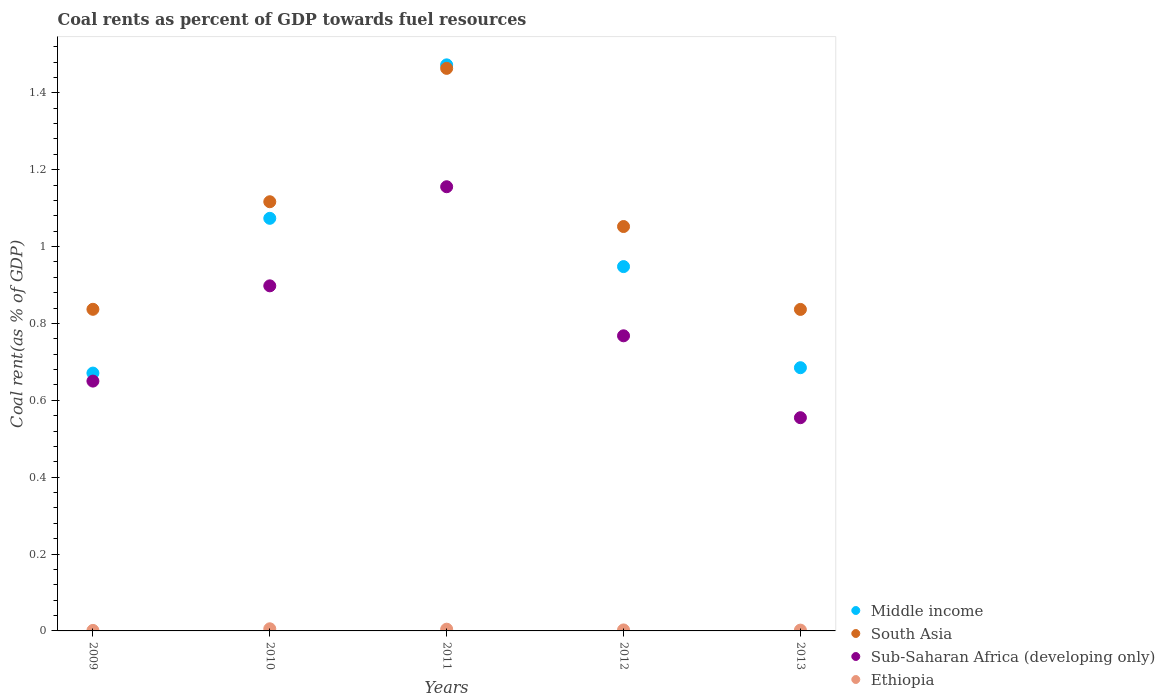How many different coloured dotlines are there?
Provide a short and direct response. 4. What is the coal rent in Middle income in 2012?
Your response must be concise. 0.95. Across all years, what is the maximum coal rent in Middle income?
Your response must be concise. 1.47. Across all years, what is the minimum coal rent in Ethiopia?
Offer a terse response. 0. In which year was the coal rent in Middle income minimum?
Provide a short and direct response. 2009. What is the total coal rent in Sub-Saharan Africa (developing only) in the graph?
Offer a very short reply. 4.03. What is the difference between the coal rent in Ethiopia in 2009 and that in 2010?
Your answer should be very brief. -0. What is the difference between the coal rent in Ethiopia in 2011 and the coal rent in Sub-Saharan Africa (developing only) in 2012?
Offer a very short reply. -0.76. What is the average coal rent in South Asia per year?
Offer a terse response. 1.06. In the year 2013, what is the difference between the coal rent in Sub-Saharan Africa (developing only) and coal rent in South Asia?
Give a very brief answer. -0.28. In how many years, is the coal rent in Ethiopia greater than 1.04 %?
Your response must be concise. 0. What is the ratio of the coal rent in Ethiopia in 2011 to that in 2013?
Your answer should be very brief. 2.17. Is the coal rent in Sub-Saharan Africa (developing only) in 2009 less than that in 2013?
Ensure brevity in your answer.  No. What is the difference between the highest and the second highest coal rent in Sub-Saharan Africa (developing only)?
Provide a short and direct response. 0.26. What is the difference between the highest and the lowest coal rent in Middle income?
Your answer should be very brief. 0.8. Is it the case that in every year, the sum of the coal rent in Sub-Saharan Africa (developing only) and coal rent in Middle income  is greater than the sum of coal rent in Ethiopia and coal rent in South Asia?
Your answer should be very brief. No. Is it the case that in every year, the sum of the coal rent in Middle income and coal rent in South Asia  is greater than the coal rent in Ethiopia?
Your answer should be compact. Yes. Does the coal rent in Middle income monotonically increase over the years?
Your answer should be compact. No. Is the coal rent in South Asia strictly greater than the coal rent in Ethiopia over the years?
Provide a succinct answer. Yes. Is the coal rent in Middle income strictly less than the coal rent in South Asia over the years?
Give a very brief answer. No. How many years are there in the graph?
Your answer should be very brief. 5. Does the graph contain any zero values?
Give a very brief answer. No. Where does the legend appear in the graph?
Your response must be concise. Bottom right. How many legend labels are there?
Provide a succinct answer. 4. What is the title of the graph?
Give a very brief answer. Coal rents as percent of GDP towards fuel resources. Does "Dominica" appear as one of the legend labels in the graph?
Ensure brevity in your answer.  No. What is the label or title of the X-axis?
Give a very brief answer. Years. What is the label or title of the Y-axis?
Offer a very short reply. Coal rent(as % of GDP). What is the Coal rent(as % of GDP) in Middle income in 2009?
Give a very brief answer. 0.67. What is the Coal rent(as % of GDP) of South Asia in 2009?
Provide a succinct answer. 0.84. What is the Coal rent(as % of GDP) of Sub-Saharan Africa (developing only) in 2009?
Keep it short and to the point. 0.65. What is the Coal rent(as % of GDP) of Ethiopia in 2009?
Make the answer very short. 0. What is the Coal rent(as % of GDP) of Middle income in 2010?
Offer a terse response. 1.07. What is the Coal rent(as % of GDP) in South Asia in 2010?
Provide a short and direct response. 1.12. What is the Coal rent(as % of GDP) in Sub-Saharan Africa (developing only) in 2010?
Provide a succinct answer. 0.9. What is the Coal rent(as % of GDP) of Ethiopia in 2010?
Offer a terse response. 0.01. What is the Coal rent(as % of GDP) of Middle income in 2011?
Offer a very short reply. 1.47. What is the Coal rent(as % of GDP) of South Asia in 2011?
Your answer should be very brief. 1.46. What is the Coal rent(as % of GDP) of Sub-Saharan Africa (developing only) in 2011?
Provide a short and direct response. 1.16. What is the Coal rent(as % of GDP) of Ethiopia in 2011?
Make the answer very short. 0. What is the Coal rent(as % of GDP) in Middle income in 2012?
Make the answer very short. 0.95. What is the Coal rent(as % of GDP) of South Asia in 2012?
Your response must be concise. 1.05. What is the Coal rent(as % of GDP) of Sub-Saharan Africa (developing only) in 2012?
Provide a short and direct response. 0.77. What is the Coal rent(as % of GDP) in Ethiopia in 2012?
Offer a very short reply. 0. What is the Coal rent(as % of GDP) of Middle income in 2013?
Give a very brief answer. 0.68. What is the Coal rent(as % of GDP) in South Asia in 2013?
Give a very brief answer. 0.84. What is the Coal rent(as % of GDP) of Sub-Saharan Africa (developing only) in 2013?
Provide a succinct answer. 0.55. What is the Coal rent(as % of GDP) in Ethiopia in 2013?
Provide a succinct answer. 0. Across all years, what is the maximum Coal rent(as % of GDP) in Middle income?
Make the answer very short. 1.47. Across all years, what is the maximum Coal rent(as % of GDP) in South Asia?
Provide a short and direct response. 1.46. Across all years, what is the maximum Coal rent(as % of GDP) of Sub-Saharan Africa (developing only)?
Your answer should be very brief. 1.16. Across all years, what is the maximum Coal rent(as % of GDP) in Ethiopia?
Keep it short and to the point. 0.01. Across all years, what is the minimum Coal rent(as % of GDP) in Middle income?
Your answer should be compact. 0.67. Across all years, what is the minimum Coal rent(as % of GDP) of South Asia?
Your response must be concise. 0.84. Across all years, what is the minimum Coal rent(as % of GDP) of Sub-Saharan Africa (developing only)?
Keep it short and to the point. 0.55. Across all years, what is the minimum Coal rent(as % of GDP) of Ethiopia?
Provide a short and direct response. 0. What is the total Coal rent(as % of GDP) in Middle income in the graph?
Make the answer very short. 4.85. What is the total Coal rent(as % of GDP) of South Asia in the graph?
Offer a very short reply. 5.3. What is the total Coal rent(as % of GDP) of Sub-Saharan Africa (developing only) in the graph?
Keep it short and to the point. 4.03. What is the total Coal rent(as % of GDP) in Ethiopia in the graph?
Give a very brief answer. 0.02. What is the difference between the Coal rent(as % of GDP) of Middle income in 2009 and that in 2010?
Offer a very short reply. -0.4. What is the difference between the Coal rent(as % of GDP) of South Asia in 2009 and that in 2010?
Offer a terse response. -0.28. What is the difference between the Coal rent(as % of GDP) in Sub-Saharan Africa (developing only) in 2009 and that in 2010?
Make the answer very short. -0.25. What is the difference between the Coal rent(as % of GDP) of Ethiopia in 2009 and that in 2010?
Your response must be concise. -0. What is the difference between the Coal rent(as % of GDP) in Middle income in 2009 and that in 2011?
Provide a succinct answer. -0.8. What is the difference between the Coal rent(as % of GDP) in South Asia in 2009 and that in 2011?
Provide a short and direct response. -0.63. What is the difference between the Coal rent(as % of GDP) of Sub-Saharan Africa (developing only) in 2009 and that in 2011?
Offer a terse response. -0.51. What is the difference between the Coal rent(as % of GDP) of Ethiopia in 2009 and that in 2011?
Provide a short and direct response. -0. What is the difference between the Coal rent(as % of GDP) in Middle income in 2009 and that in 2012?
Your answer should be very brief. -0.28. What is the difference between the Coal rent(as % of GDP) of South Asia in 2009 and that in 2012?
Ensure brevity in your answer.  -0.22. What is the difference between the Coal rent(as % of GDP) of Sub-Saharan Africa (developing only) in 2009 and that in 2012?
Offer a very short reply. -0.12. What is the difference between the Coal rent(as % of GDP) in Ethiopia in 2009 and that in 2012?
Your answer should be compact. -0. What is the difference between the Coal rent(as % of GDP) in Middle income in 2009 and that in 2013?
Offer a terse response. -0.01. What is the difference between the Coal rent(as % of GDP) in Sub-Saharan Africa (developing only) in 2009 and that in 2013?
Provide a short and direct response. 0.1. What is the difference between the Coal rent(as % of GDP) in Ethiopia in 2009 and that in 2013?
Make the answer very short. -0. What is the difference between the Coal rent(as % of GDP) in Middle income in 2010 and that in 2011?
Offer a very short reply. -0.4. What is the difference between the Coal rent(as % of GDP) in South Asia in 2010 and that in 2011?
Offer a very short reply. -0.35. What is the difference between the Coal rent(as % of GDP) in Sub-Saharan Africa (developing only) in 2010 and that in 2011?
Provide a succinct answer. -0.26. What is the difference between the Coal rent(as % of GDP) in Ethiopia in 2010 and that in 2011?
Your response must be concise. 0. What is the difference between the Coal rent(as % of GDP) in Middle income in 2010 and that in 2012?
Give a very brief answer. 0.13. What is the difference between the Coal rent(as % of GDP) of South Asia in 2010 and that in 2012?
Offer a very short reply. 0.06. What is the difference between the Coal rent(as % of GDP) in Sub-Saharan Africa (developing only) in 2010 and that in 2012?
Your response must be concise. 0.13. What is the difference between the Coal rent(as % of GDP) in Ethiopia in 2010 and that in 2012?
Make the answer very short. 0. What is the difference between the Coal rent(as % of GDP) in Middle income in 2010 and that in 2013?
Offer a very short reply. 0.39. What is the difference between the Coal rent(as % of GDP) of South Asia in 2010 and that in 2013?
Provide a succinct answer. 0.28. What is the difference between the Coal rent(as % of GDP) of Sub-Saharan Africa (developing only) in 2010 and that in 2013?
Keep it short and to the point. 0.34. What is the difference between the Coal rent(as % of GDP) in Ethiopia in 2010 and that in 2013?
Give a very brief answer. 0. What is the difference between the Coal rent(as % of GDP) in Middle income in 2011 and that in 2012?
Give a very brief answer. 0.52. What is the difference between the Coal rent(as % of GDP) of South Asia in 2011 and that in 2012?
Give a very brief answer. 0.41. What is the difference between the Coal rent(as % of GDP) in Sub-Saharan Africa (developing only) in 2011 and that in 2012?
Ensure brevity in your answer.  0.39. What is the difference between the Coal rent(as % of GDP) in Ethiopia in 2011 and that in 2012?
Give a very brief answer. 0. What is the difference between the Coal rent(as % of GDP) in Middle income in 2011 and that in 2013?
Make the answer very short. 0.79. What is the difference between the Coal rent(as % of GDP) in South Asia in 2011 and that in 2013?
Offer a very short reply. 0.63. What is the difference between the Coal rent(as % of GDP) in Sub-Saharan Africa (developing only) in 2011 and that in 2013?
Keep it short and to the point. 0.6. What is the difference between the Coal rent(as % of GDP) in Ethiopia in 2011 and that in 2013?
Offer a terse response. 0. What is the difference between the Coal rent(as % of GDP) of Middle income in 2012 and that in 2013?
Your answer should be very brief. 0.26. What is the difference between the Coal rent(as % of GDP) of South Asia in 2012 and that in 2013?
Provide a short and direct response. 0.22. What is the difference between the Coal rent(as % of GDP) of Sub-Saharan Africa (developing only) in 2012 and that in 2013?
Ensure brevity in your answer.  0.21. What is the difference between the Coal rent(as % of GDP) in Middle income in 2009 and the Coal rent(as % of GDP) in South Asia in 2010?
Give a very brief answer. -0.45. What is the difference between the Coal rent(as % of GDP) of Middle income in 2009 and the Coal rent(as % of GDP) of Sub-Saharan Africa (developing only) in 2010?
Your answer should be very brief. -0.23. What is the difference between the Coal rent(as % of GDP) of Middle income in 2009 and the Coal rent(as % of GDP) of Ethiopia in 2010?
Your answer should be compact. 0.67. What is the difference between the Coal rent(as % of GDP) of South Asia in 2009 and the Coal rent(as % of GDP) of Sub-Saharan Africa (developing only) in 2010?
Offer a very short reply. -0.06. What is the difference between the Coal rent(as % of GDP) in South Asia in 2009 and the Coal rent(as % of GDP) in Ethiopia in 2010?
Provide a succinct answer. 0.83. What is the difference between the Coal rent(as % of GDP) in Sub-Saharan Africa (developing only) in 2009 and the Coal rent(as % of GDP) in Ethiopia in 2010?
Provide a succinct answer. 0.64. What is the difference between the Coal rent(as % of GDP) of Middle income in 2009 and the Coal rent(as % of GDP) of South Asia in 2011?
Provide a succinct answer. -0.79. What is the difference between the Coal rent(as % of GDP) in Middle income in 2009 and the Coal rent(as % of GDP) in Sub-Saharan Africa (developing only) in 2011?
Offer a very short reply. -0.48. What is the difference between the Coal rent(as % of GDP) in Middle income in 2009 and the Coal rent(as % of GDP) in Ethiopia in 2011?
Provide a short and direct response. 0.67. What is the difference between the Coal rent(as % of GDP) of South Asia in 2009 and the Coal rent(as % of GDP) of Sub-Saharan Africa (developing only) in 2011?
Your response must be concise. -0.32. What is the difference between the Coal rent(as % of GDP) of South Asia in 2009 and the Coal rent(as % of GDP) of Ethiopia in 2011?
Keep it short and to the point. 0.83. What is the difference between the Coal rent(as % of GDP) of Sub-Saharan Africa (developing only) in 2009 and the Coal rent(as % of GDP) of Ethiopia in 2011?
Your response must be concise. 0.65. What is the difference between the Coal rent(as % of GDP) in Middle income in 2009 and the Coal rent(as % of GDP) in South Asia in 2012?
Keep it short and to the point. -0.38. What is the difference between the Coal rent(as % of GDP) in Middle income in 2009 and the Coal rent(as % of GDP) in Sub-Saharan Africa (developing only) in 2012?
Give a very brief answer. -0.1. What is the difference between the Coal rent(as % of GDP) in Middle income in 2009 and the Coal rent(as % of GDP) in Ethiopia in 2012?
Provide a succinct answer. 0.67. What is the difference between the Coal rent(as % of GDP) in South Asia in 2009 and the Coal rent(as % of GDP) in Sub-Saharan Africa (developing only) in 2012?
Your response must be concise. 0.07. What is the difference between the Coal rent(as % of GDP) in South Asia in 2009 and the Coal rent(as % of GDP) in Ethiopia in 2012?
Keep it short and to the point. 0.83. What is the difference between the Coal rent(as % of GDP) in Sub-Saharan Africa (developing only) in 2009 and the Coal rent(as % of GDP) in Ethiopia in 2012?
Provide a short and direct response. 0.65. What is the difference between the Coal rent(as % of GDP) of Middle income in 2009 and the Coal rent(as % of GDP) of South Asia in 2013?
Give a very brief answer. -0.17. What is the difference between the Coal rent(as % of GDP) in Middle income in 2009 and the Coal rent(as % of GDP) in Sub-Saharan Africa (developing only) in 2013?
Make the answer very short. 0.12. What is the difference between the Coal rent(as % of GDP) in Middle income in 2009 and the Coal rent(as % of GDP) in Ethiopia in 2013?
Your answer should be very brief. 0.67. What is the difference between the Coal rent(as % of GDP) in South Asia in 2009 and the Coal rent(as % of GDP) in Sub-Saharan Africa (developing only) in 2013?
Your answer should be very brief. 0.28. What is the difference between the Coal rent(as % of GDP) in South Asia in 2009 and the Coal rent(as % of GDP) in Ethiopia in 2013?
Your response must be concise. 0.83. What is the difference between the Coal rent(as % of GDP) in Sub-Saharan Africa (developing only) in 2009 and the Coal rent(as % of GDP) in Ethiopia in 2013?
Your answer should be compact. 0.65. What is the difference between the Coal rent(as % of GDP) in Middle income in 2010 and the Coal rent(as % of GDP) in South Asia in 2011?
Provide a short and direct response. -0.39. What is the difference between the Coal rent(as % of GDP) in Middle income in 2010 and the Coal rent(as % of GDP) in Sub-Saharan Africa (developing only) in 2011?
Your response must be concise. -0.08. What is the difference between the Coal rent(as % of GDP) of Middle income in 2010 and the Coal rent(as % of GDP) of Ethiopia in 2011?
Keep it short and to the point. 1.07. What is the difference between the Coal rent(as % of GDP) of South Asia in 2010 and the Coal rent(as % of GDP) of Sub-Saharan Africa (developing only) in 2011?
Your response must be concise. -0.04. What is the difference between the Coal rent(as % of GDP) of South Asia in 2010 and the Coal rent(as % of GDP) of Ethiopia in 2011?
Make the answer very short. 1.11. What is the difference between the Coal rent(as % of GDP) in Sub-Saharan Africa (developing only) in 2010 and the Coal rent(as % of GDP) in Ethiopia in 2011?
Give a very brief answer. 0.89. What is the difference between the Coal rent(as % of GDP) of Middle income in 2010 and the Coal rent(as % of GDP) of South Asia in 2012?
Give a very brief answer. 0.02. What is the difference between the Coal rent(as % of GDP) of Middle income in 2010 and the Coal rent(as % of GDP) of Sub-Saharan Africa (developing only) in 2012?
Provide a succinct answer. 0.31. What is the difference between the Coal rent(as % of GDP) of Middle income in 2010 and the Coal rent(as % of GDP) of Ethiopia in 2012?
Your answer should be very brief. 1.07. What is the difference between the Coal rent(as % of GDP) in South Asia in 2010 and the Coal rent(as % of GDP) in Sub-Saharan Africa (developing only) in 2012?
Your response must be concise. 0.35. What is the difference between the Coal rent(as % of GDP) in South Asia in 2010 and the Coal rent(as % of GDP) in Ethiopia in 2012?
Provide a short and direct response. 1.11. What is the difference between the Coal rent(as % of GDP) of Sub-Saharan Africa (developing only) in 2010 and the Coal rent(as % of GDP) of Ethiopia in 2012?
Provide a short and direct response. 0.9. What is the difference between the Coal rent(as % of GDP) in Middle income in 2010 and the Coal rent(as % of GDP) in South Asia in 2013?
Offer a very short reply. 0.24. What is the difference between the Coal rent(as % of GDP) in Middle income in 2010 and the Coal rent(as % of GDP) in Sub-Saharan Africa (developing only) in 2013?
Give a very brief answer. 0.52. What is the difference between the Coal rent(as % of GDP) in Middle income in 2010 and the Coal rent(as % of GDP) in Ethiopia in 2013?
Provide a succinct answer. 1.07. What is the difference between the Coal rent(as % of GDP) of South Asia in 2010 and the Coal rent(as % of GDP) of Sub-Saharan Africa (developing only) in 2013?
Offer a very short reply. 0.56. What is the difference between the Coal rent(as % of GDP) in South Asia in 2010 and the Coal rent(as % of GDP) in Ethiopia in 2013?
Offer a very short reply. 1.11. What is the difference between the Coal rent(as % of GDP) of Sub-Saharan Africa (developing only) in 2010 and the Coal rent(as % of GDP) of Ethiopia in 2013?
Ensure brevity in your answer.  0.9. What is the difference between the Coal rent(as % of GDP) in Middle income in 2011 and the Coal rent(as % of GDP) in South Asia in 2012?
Ensure brevity in your answer.  0.42. What is the difference between the Coal rent(as % of GDP) of Middle income in 2011 and the Coal rent(as % of GDP) of Sub-Saharan Africa (developing only) in 2012?
Make the answer very short. 0.7. What is the difference between the Coal rent(as % of GDP) of Middle income in 2011 and the Coal rent(as % of GDP) of Ethiopia in 2012?
Offer a very short reply. 1.47. What is the difference between the Coal rent(as % of GDP) in South Asia in 2011 and the Coal rent(as % of GDP) in Sub-Saharan Africa (developing only) in 2012?
Keep it short and to the point. 0.7. What is the difference between the Coal rent(as % of GDP) in South Asia in 2011 and the Coal rent(as % of GDP) in Ethiopia in 2012?
Your response must be concise. 1.46. What is the difference between the Coal rent(as % of GDP) in Sub-Saharan Africa (developing only) in 2011 and the Coal rent(as % of GDP) in Ethiopia in 2012?
Ensure brevity in your answer.  1.15. What is the difference between the Coal rent(as % of GDP) in Middle income in 2011 and the Coal rent(as % of GDP) in South Asia in 2013?
Offer a terse response. 0.64. What is the difference between the Coal rent(as % of GDP) in Middle income in 2011 and the Coal rent(as % of GDP) in Sub-Saharan Africa (developing only) in 2013?
Give a very brief answer. 0.92. What is the difference between the Coal rent(as % of GDP) of Middle income in 2011 and the Coal rent(as % of GDP) of Ethiopia in 2013?
Provide a short and direct response. 1.47. What is the difference between the Coal rent(as % of GDP) of South Asia in 2011 and the Coal rent(as % of GDP) of Sub-Saharan Africa (developing only) in 2013?
Your answer should be compact. 0.91. What is the difference between the Coal rent(as % of GDP) of South Asia in 2011 and the Coal rent(as % of GDP) of Ethiopia in 2013?
Provide a short and direct response. 1.46. What is the difference between the Coal rent(as % of GDP) of Sub-Saharan Africa (developing only) in 2011 and the Coal rent(as % of GDP) of Ethiopia in 2013?
Offer a very short reply. 1.15. What is the difference between the Coal rent(as % of GDP) in Middle income in 2012 and the Coal rent(as % of GDP) in South Asia in 2013?
Your response must be concise. 0.11. What is the difference between the Coal rent(as % of GDP) of Middle income in 2012 and the Coal rent(as % of GDP) of Sub-Saharan Africa (developing only) in 2013?
Keep it short and to the point. 0.39. What is the difference between the Coal rent(as % of GDP) of Middle income in 2012 and the Coal rent(as % of GDP) of Ethiopia in 2013?
Offer a very short reply. 0.95. What is the difference between the Coal rent(as % of GDP) of South Asia in 2012 and the Coal rent(as % of GDP) of Sub-Saharan Africa (developing only) in 2013?
Ensure brevity in your answer.  0.5. What is the difference between the Coal rent(as % of GDP) of South Asia in 2012 and the Coal rent(as % of GDP) of Ethiopia in 2013?
Give a very brief answer. 1.05. What is the difference between the Coal rent(as % of GDP) of Sub-Saharan Africa (developing only) in 2012 and the Coal rent(as % of GDP) of Ethiopia in 2013?
Offer a terse response. 0.77. What is the average Coal rent(as % of GDP) in Middle income per year?
Offer a terse response. 0.97. What is the average Coal rent(as % of GDP) in South Asia per year?
Offer a terse response. 1.06. What is the average Coal rent(as % of GDP) in Sub-Saharan Africa (developing only) per year?
Offer a very short reply. 0.81. What is the average Coal rent(as % of GDP) in Ethiopia per year?
Your answer should be compact. 0. In the year 2009, what is the difference between the Coal rent(as % of GDP) in Middle income and Coal rent(as % of GDP) in South Asia?
Your answer should be very brief. -0.17. In the year 2009, what is the difference between the Coal rent(as % of GDP) in Middle income and Coal rent(as % of GDP) in Sub-Saharan Africa (developing only)?
Your answer should be compact. 0.02. In the year 2009, what is the difference between the Coal rent(as % of GDP) of Middle income and Coal rent(as % of GDP) of Ethiopia?
Provide a succinct answer. 0.67. In the year 2009, what is the difference between the Coal rent(as % of GDP) in South Asia and Coal rent(as % of GDP) in Sub-Saharan Africa (developing only)?
Your answer should be very brief. 0.19. In the year 2009, what is the difference between the Coal rent(as % of GDP) of South Asia and Coal rent(as % of GDP) of Ethiopia?
Give a very brief answer. 0.84. In the year 2009, what is the difference between the Coal rent(as % of GDP) in Sub-Saharan Africa (developing only) and Coal rent(as % of GDP) in Ethiopia?
Your answer should be compact. 0.65. In the year 2010, what is the difference between the Coal rent(as % of GDP) in Middle income and Coal rent(as % of GDP) in South Asia?
Provide a short and direct response. -0.04. In the year 2010, what is the difference between the Coal rent(as % of GDP) in Middle income and Coal rent(as % of GDP) in Sub-Saharan Africa (developing only)?
Offer a very short reply. 0.18. In the year 2010, what is the difference between the Coal rent(as % of GDP) in Middle income and Coal rent(as % of GDP) in Ethiopia?
Offer a very short reply. 1.07. In the year 2010, what is the difference between the Coal rent(as % of GDP) of South Asia and Coal rent(as % of GDP) of Sub-Saharan Africa (developing only)?
Provide a succinct answer. 0.22. In the year 2010, what is the difference between the Coal rent(as % of GDP) of South Asia and Coal rent(as % of GDP) of Ethiopia?
Your response must be concise. 1.11. In the year 2010, what is the difference between the Coal rent(as % of GDP) of Sub-Saharan Africa (developing only) and Coal rent(as % of GDP) of Ethiopia?
Provide a succinct answer. 0.89. In the year 2011, what is the difference between the Coal rent(as % of GDP) in Middle income and Coal rent(as % of GDP) in South Asia?
Provide a short and direct response. 0.01. In the year 2011, what is the difference between the Coal rent(as % of GDP) in Middle income and Coal rent(as % of GDP) in Sub-Saharan Africa (developing only)?
Give a very brief answer. 0.32. In the year 2011, what is the difference between the Coal rent(as % of GDP) of Middle income and Coal rent(as % of GDP) of Ethiopia?
Your response must be concise. 1.47. In the year 2011, what is the difference between the Coal rent(as % of GDP) of South Asia and Coal rent(as % of GDP) of Sub-Saharan Africa (developing only)?
Ensure brevity in your answer.  0.31. In the year 2011, what is the difference between the Coal rent(as % of GDP) in South Asia and Coal rent(as % of GDP) in Ethiopia?
Make the answer very short. 1.46. In the year 2011, what is the difference between the Coal rent(as % of GDP) in Sub-Saharan Africa (developing only) and Coal rent(as % of GDP) in Ethiopia?
Provide a succinct answer. 1.15. In the year 2012, what is the difference between the Coal rent(as % of GDP) in Middle income and Coal rent(as % of GDP) in South Asia?
Provide a succinct answer. -0.1. In the year 2012, what is the difference between the Coal rent(as % of GDP) in Middle income and Coal rent(as % of GDP) in Sub-Saharan Africa (developing only)?
Provide a short and direct response. 0.18. In the year 2012, what is the difference between the Coal rent(as % of GDP) of Middle income and Coal rent(as % of GDP) of Ethiopia?
Ensure brevity in your answer.  0.95. In the year 2012, what is the difference between the Coal rent(as % of GDP) in South Asia and Coal rent(as % of GDP) in Sub-Saharan Africa (developing only)?
Offer a very short reply. 0.28. In the year 2012, what is the difference between the Coal rent(as % of GDP) in South Asia and Coal rent(as % of GDP) in Ethiopia?
Offer a terse response. 1.05. In the year 2012, what is the difference between the Coal rent(as % of GDP) of Sub-Saharan Africa (developing only) and Coal rent(as % of GDP) of Ethiopia?
Your response must be concise. 0.77. In the year 2013, what is the difference between the Coal rent(as % of GDP) in Middle income and Coal rent(as % of GDP) in South Asia?
Your response must be concise. -0.15. In the year 2013, what is the difference between the Coal rent(as % of GDP) of Middle income and Coal rent(as % of GDP) of Sub-Saharan Africa (developing only)?
Your answer should be compact. 0.13. In the year 2013, what is the difference between the Coal rent(as % of GDP) in Middle income and Coal rent(as % of GDP) in Ethiopia?
Ensure brevity in your answer.  0.68. In the year 2013, what is the difference between the Coal rent(as % of GDP) in South Asia and Coal rent(as % of GDP) in Sub-Saharan Africa (developing only)?
Make the answer very short. 0.28. In the year 2013, what is the difference between the Coal rent(as % of GDP) of South Asia and Coal rent(as % of GDP) of Ethiopia?
Your answer should be compact. 0.83. In the year 2013, what is the difference between the Coal rent(as % of GDP) of Sub-Saharan Africa (developing only) and Coal rent(as % of GDP) of Ethiopia?
Ensure brevity in your answer.  0.55. What is the ratio of the Coal rent(as % of GDP) in Middle income in 2009 to that in 2010?
Offer a very short reply. 0.62. What is the ratio of the Coal rent(as % of GDP) of South Asia in 2009 to that in 2010?
Your response must be concise. 0.75. What is the ratio of the Coal rent(as % of GDP) in Sub-Saharan Africa (developing only) in 2009 to that in 2010?
Ensure brevity in your answer.  0.72. What is the ratio of the Coal rent(as % of GDP) in Ethiopia in 2009 to that in 2010?
Offer a terse response. 0.24. What is the ratio of the Coal rent(as % of GDP) in Middle income in 2009 to that in 2011?
Offer a terse response. 0.46. What is the ratio of the Coal rent(as % of GDP) of South Asia in 2009 to that in 2011?
Your answer should be compact. 0.57. What is the ratio of the Coal rent(as % of GDP) in Sub-Saharan Africa (developing only) in 2009 to that in 2011?
Make the answer very short. 0.56. What is the ratio of the Coal rent(as % of GDP) of Ethiopia in 2009 to that in 2011?
Provide a succinct answer. 0.29. What is the ratio of the Coal rent(as % of GDP) of Middle income in 2009 to that in 2012?
Give a very brief answer. 0.71. What is the ratio of the Coal rent(as % of GDP) of South Asia in 2009 to that in 2012?
Offer a terse response. 0.8. What is the ratio of the Coal rent(as % of GDP) in Sub-Saharan Africa (developing only) in 2009 to that in 2012?
Keep it short and to the point. 0.85. What is the ratio of the Coal rent(as % of GDP) of Ethiopia in 2009 to that in 2012?
Ensure brevity in your answer.  0.51. What is the ratio of the Coal rent(as % of GDP) of Middle income in 2009 to that in 2013?
Provide a succinct answer. 0.98. What is the ratio of the Coal rent(as % of GDP) of South Asia in 2009 to that in 2013?
Ensure brevity in your answer.  1. What is the ratio of the Coal rent(as % of GDP) of Sub-Saharan Africa (developing only) in 2009 to that in 2013?
Your answer should be very brief. 1.17. What is the ratio of the Coal rent(as % of GDP) of Ethiopia in 2009 to that in 2013?
Keep it short and to the point. 0.63. What is the ratio of the Coal rent(as % of GDP) of Middle income in 2010 to that in 2011?
Offer a very short reply. 0.73. What is the ratio of the Coal rent(as % of GDP) in South Asia in 2010 to that in 2011?
Offer a very short reply. 0.76. What is the ratio of the Coal rent(as % of GDP) of Sub-Saharan Africa (developing only) in 2010 to that in 2011?
Offer a terse response. 0.78. What is the ratio of the Coal rent(as % of GDP) in Ethiopia in 2010 to that in 2011?
Ensure brevity in your answer.  1.23. What is the ratio of the Coal rent(as % of GDP) of Middle income in 2010 to that in 2012?
Provide a succinct answer. 1.13. What is the ratio of the Coal rent(as % of GDP) in South Asia in 2010 to that in 2012?
Offer a very short reply. 1.06. What is the ratio of the Coal rent(as % of GDP) in Sub-Saharan Africa (developing only) in 2010 to that in 2012?
Keep it short and to the point. 1.17. What is the ratio of the Coal rent(as % of GDP) of Ethiopia in 2010 to that in 2012?
Give a very brief answer. 2.16. What is the ratio of the Coal rent(as % of GDP) in Middle income in 2010 to that in 2013?
Keep it short and to the point. 1.57. What is the ratio of the Coal rent(as % of GDP) of South Asia in 2010 to that in 2013?
Ensure brevity in your answer.  1.33. What is the ratio of the Coal rent(as % of GDP) in Sub-Saharan Africa (developing only) in 2010 to that in 2013?
Your answer should be compact. 1.62. What is the ratio of the Coal rent(as % of GDP) of Ethiopia in 2010 to that in 2013?
Offer a terse response. 2.66. What is the ratio of the Coal rent(as % of GDP) of Middle income in 2011 to that in 2012?
Your response must be concise. 1.55. What is the ratio of the Coal rent(as % of GDP) of South Asia in 2011 to that in 2012?
Make the answer very short. 1.39. What is the ratio of the Coal rent(as % of GDP) in Sub-Saharan Africa (developing only) in 2011 to that in 2012?
Offer a terse response. 1.51. What is the ratio of the Coal rent(as % of GDP) of Ethiopia in 2011 to that in 2012?
Give a very brief answer. 1.76. What is the ratio of the Coal rent(as % of GDP) in Middle income in 2011 to that in 2013?
Your response must be concise. 2.15. What is the ratio of the Coal rent(as % of GDP) in South Asia in 2011 to that in 2013?
Ensure brevity in your answer.  1.75. What is the ratio of the Coal rent(as % of GDP) in Sub-Saharan Africa (developing only) in 2011 to that in 2013?
Your answer should be compact. 2.08. What is the ratio of the Coal rent(as % of GDP) of Ethiopia in 2011 to that in 2013?
Make the answer very short. 2.17. What is the ratio of the Coal rent(as % of GDP) in Middle income in 2012 to that in 2013?
Provide a short and direct response. 1.38. What is the ratio of the Coal rent(as % of GDP) in South Asia in 2012 to that in 2013?
Give a very brief answer. 1.26. What is the ratio of the Coal rent(as % of GDP) in Sub-Saharan Africa (developing only) in 2012 to that in 2013?
Your answer should be compact. 1.38. What is the ratio of the Coal rent(as % of GDP) in Ethiopia in 2012 to that in 2013?
Make the answer very short. 1.23. What is the difference between the highest and the second highest Coal rent(as % of GDP) of Middle income?
Provide a short and direct response. 0.4. What is the difference between the highest and the second highest Coal rent(as % of GDP) in South Asia?
Your answer should be compact. 0.35. What is the difference between the highest and the second highest Coal rent(as % of GDP) of Sub-Saharan Africa (developing only)?
Your answer should be very brief. 0.26. What is the difference between the highest and the second highest Coal rent(as % of GDP) of Ethiopia?
Keep it short and to the point. 0. What is the difference between the highest and the lowest Coal rent(as % of GDP) in Middle income?
Provide a short and direct response. 0.8. What is the difference between the highest and the lowest Coal rent(as % of GDP) of South Asia?
Provide a succinct answer. 0.63. What is the difference between the highest and the lowest Coal rent(as % of GDP) of Sub-Saharan Africa (developing only)?
Your response must be concise. 0.6. What is the difference between the highest and the lowest Coal rent(as % of GDP) of Ethiopia?
Offer a very short reply. 0. 